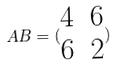Convert formula to latex. <formula><loc_0><loc_0><loc_500><loc_500>A B = ( \begin{matrix} 4 & 6 \\ 6 & 2 \end{matrix} )</formula> 